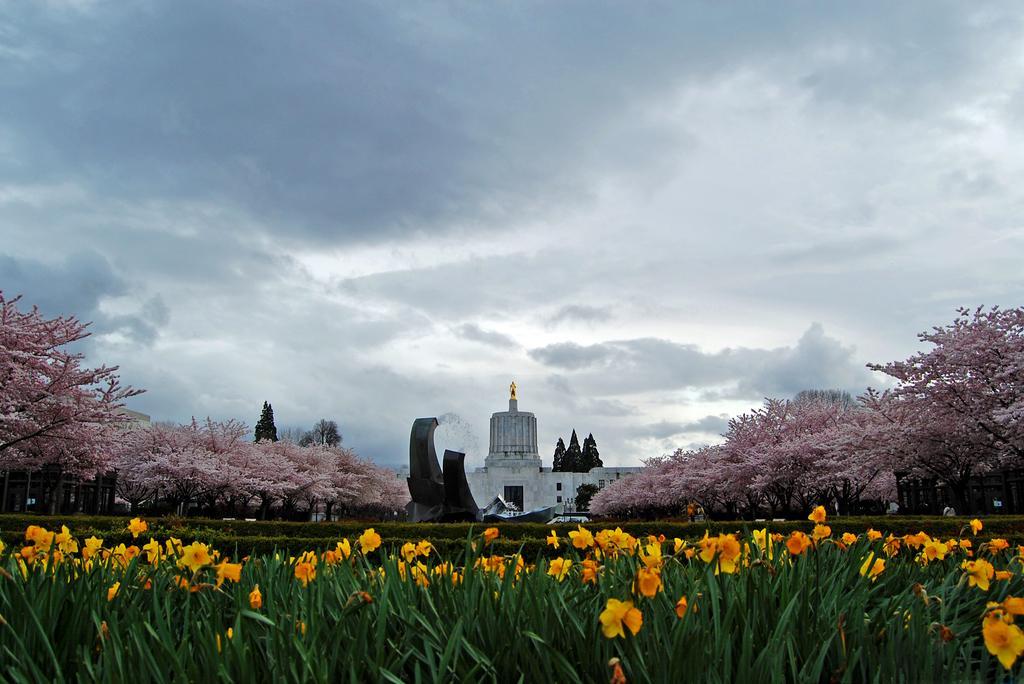How would you summarize this image in a sentence or two? This image consists of a building, beside which there are many trees. At the bottom, there are flowers along with plants. At the top, there are clouds in the sky. 